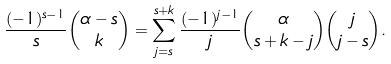Convert formula to latex. <formula><loc_0><loc_0><loc_500><loc_500>\frac { ( - 1 ) ^ { s - 1 } } { s } \binom { \alpha - s } { k } = \sum _ { j = s } ^ { s + k } \frac { ( - 1 ) ^ { j - 1 } } { j } \binom { \alpha } { s + k - j } \binom { j } { j - s } .</formula> 